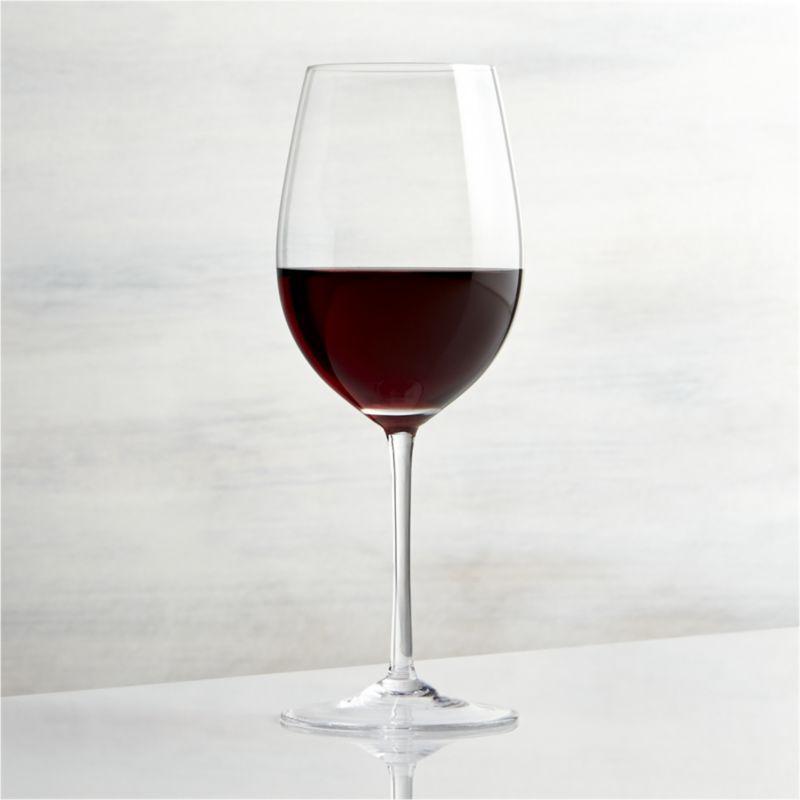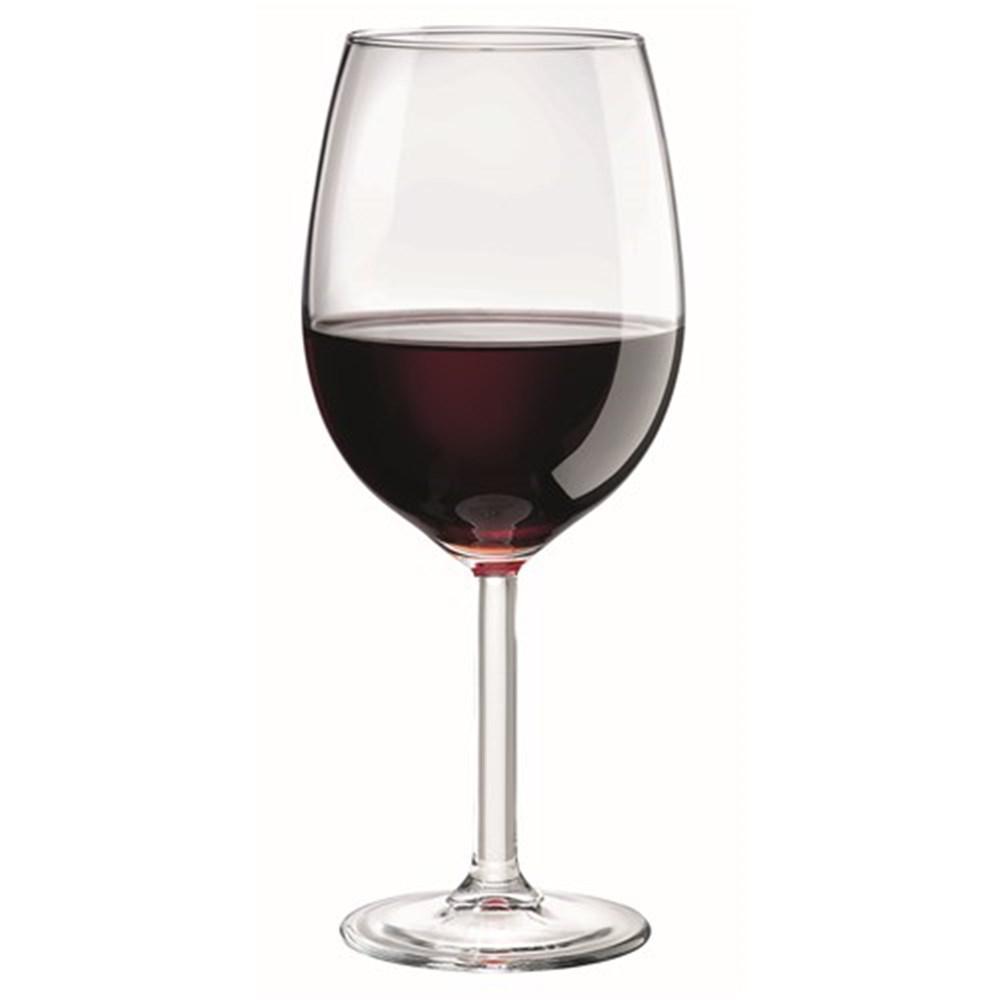The first image is the image on the left, the second image is the image on the right. For the images displayed, is the sentence "The reflection of the wineglass can be seen in the surface upon which it is sitting in the image on the left." factually correct? Answer yes or no. Yes. 